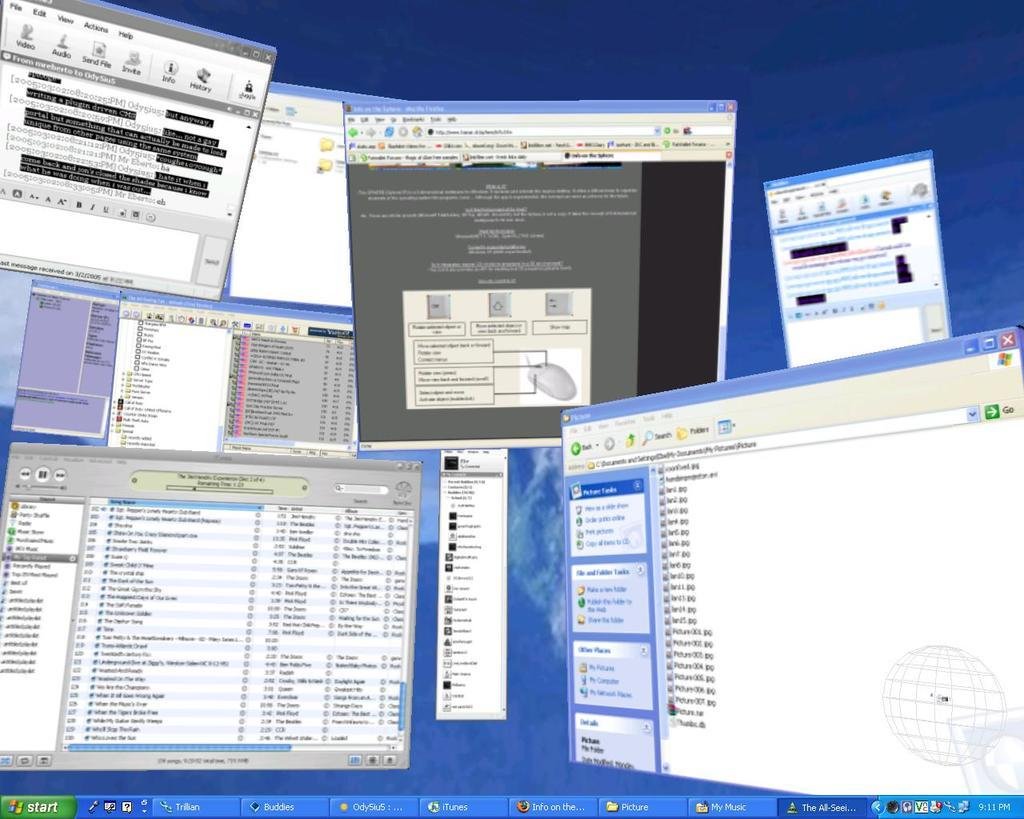What electronic device is visible in the image? There is a monitor in the image. What is the monitor displaying? The monitor has multiple tabs open. Can you see any pets interacting with the monitor in the image? There is no pet present in the image. Is there a gun visible on the screen of the monitor in the image? There is no gun visible on the screen of the monitor in the image. 